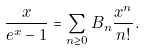Convert formula to latex. <formula><loc_0><loc_0><loc_500><loc_500>\frac { x } { e ^ { x } - 1 } = \sum _ { n \geq 0 } B _ { n } \frac { x ^ { n } } { n ! } .</formula> 